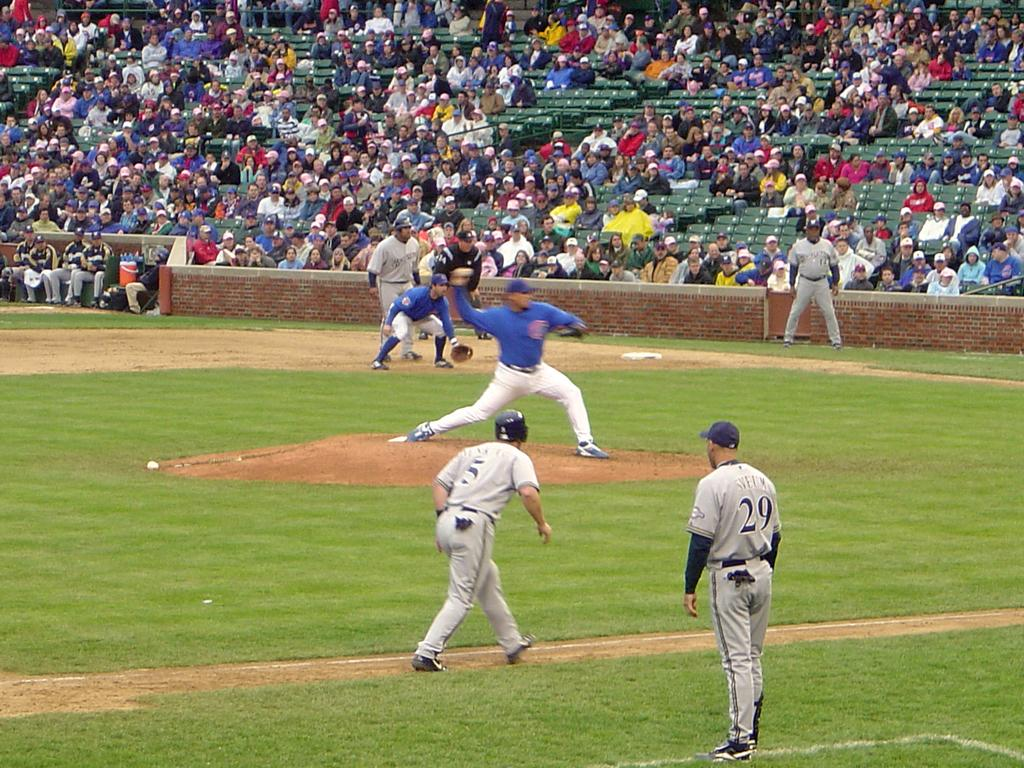<image>
Provide a brief description of the given image. A baseball player in blue throws the ball as number five and twenty nine in grey look on. 